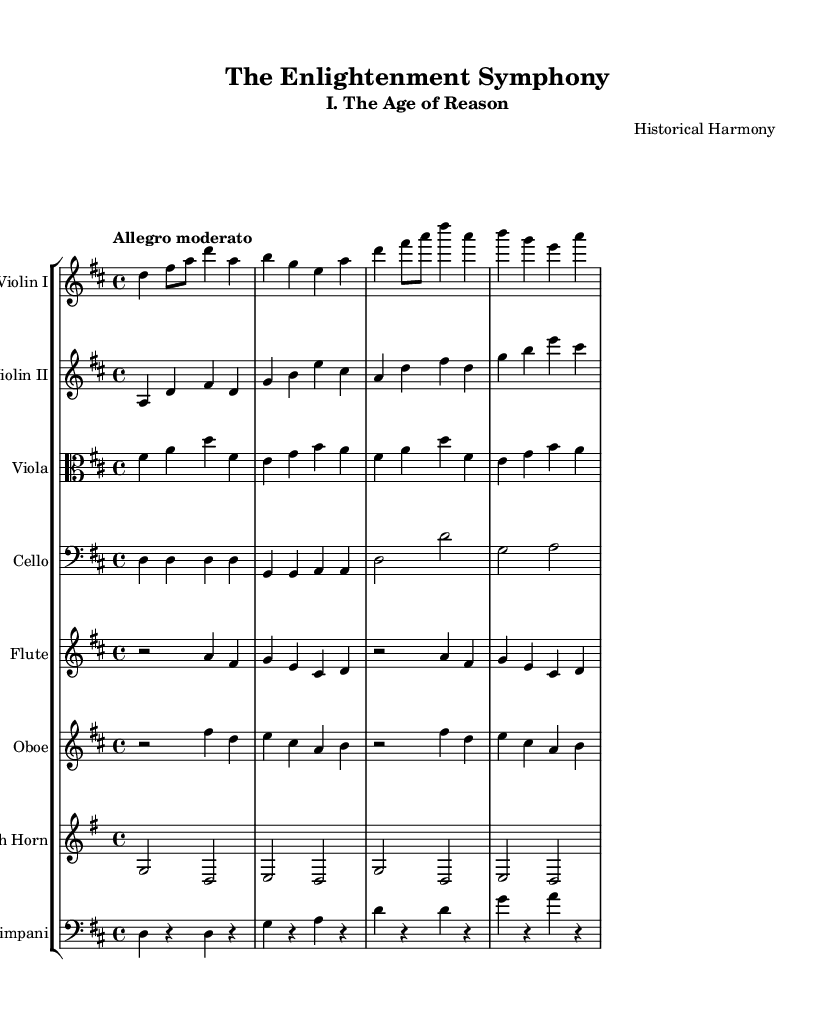What is the title of this composition? The title of the composition is indicated at the top of the sheet music under the header section. It reads "The Enlightenment Symphony."
Answer: The Enlightenment Symphony What is the key signature of this music? The key signature for this piece is denoted by the sharps and flats at the beginning of the staff. In this case, it is D major, which has two sharps.
Answer: D major What is the time signature of this composition? The time signature is found right at the beginning of the music staff, indicated as a fraction. It is marked as 4/4, meaning four beats in a measure.
Answer: 4/4 What is the tempo marking of this piece? The tempo marking is specified in the global set at the start, which says "Allegro moderato," indicating the speed at which the piece should be played.
Answer: Allegro moderato How many instruments are indicated in the score? The score section shows multiple staff lines for each instrument, and by counting them, we find a total of eight different instruments listed: Violin I, Violin II, Viola, Cello, Flute, Oboe, French Horn, and Timpani.
Answer: Eight What is the musical form of this piece based on its title and subtitle? Given the title "The Enlightenment Symphony" and the subtitle "I. The Age of Reason," it suggests that this musical composition follows a symphonic form, often characterized by multiple movements, focusing on themes of the enlightenment period.
Answer: Symphony What instrument has the highest pitch in this score? In the provided sheet music, the flute part is typically written in a higher register compared to the other instruments, such as the strings and horn. Therefore, the flute has the highest pitch.
Answer: Flute 